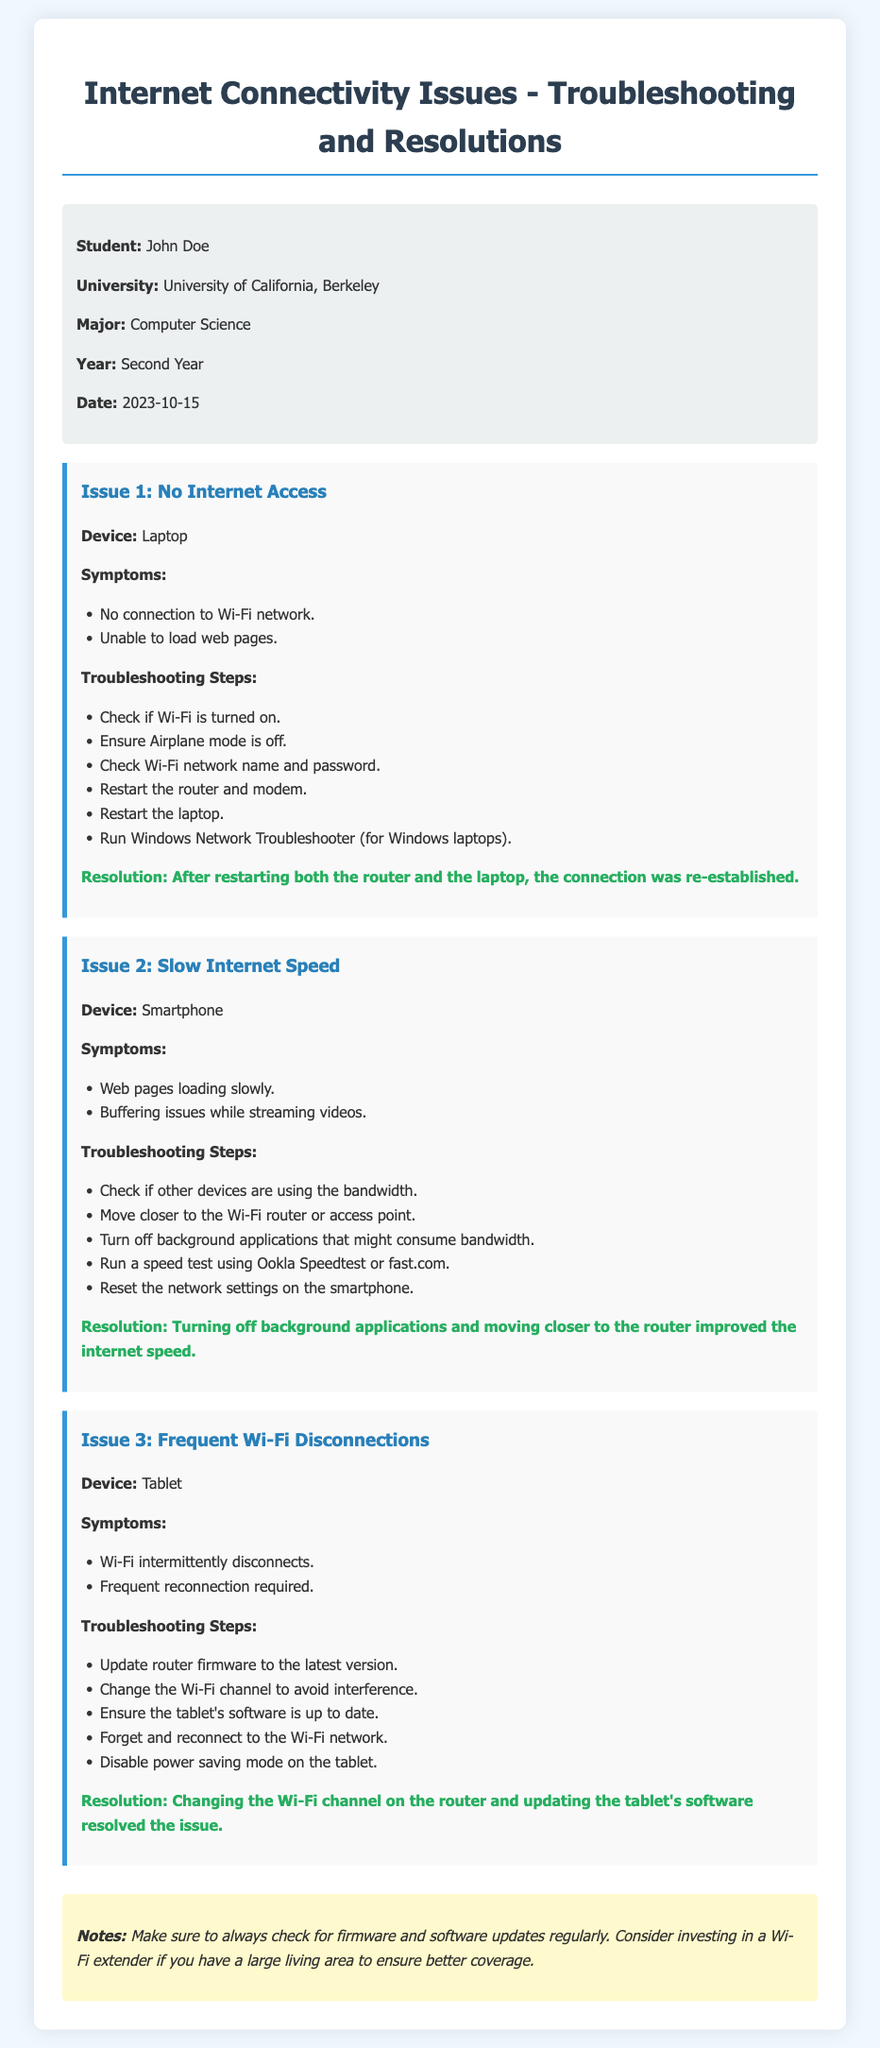What is the name of the student? The student's name is mentioned in the student info section.
Answer: John Doe What is the major of the student? The major is specified as part of the student information.
Answer: Computer Science What date was the maintenance log created? The date is clearly stated in the student info section.
Answer: 2023-10-15 What was the first issue listed? The first issue is identified in the document as "No Internet Access."
Answer: No Internet Access What troubleshooting step is suggested for slow internet speed? Steps listed under "Slow Internet Speed" include checking other devices or running a speed test.
Answer: Check if other devices are using the bandwidth What is the resolution for the issue of frequent Wi-Fi disconnections? The resolution section provides the outcome after troubleshooting the issue.
Answer: Changing the Wi-Fi channel on the router and updating the tablet's software resolved the issue What background color is used for the student info section? The document describes the styling applied to the student info section, including the background color.
Answer: Light gray How many issues are documented in total? The document presents three distinct issues related to internet connectivity.
Answer: Three Which device had the issue of slow internet speed? The device associated with the "Slow Internet Speed" issue is mentioned in the issue section.
Answer: Smartphone 